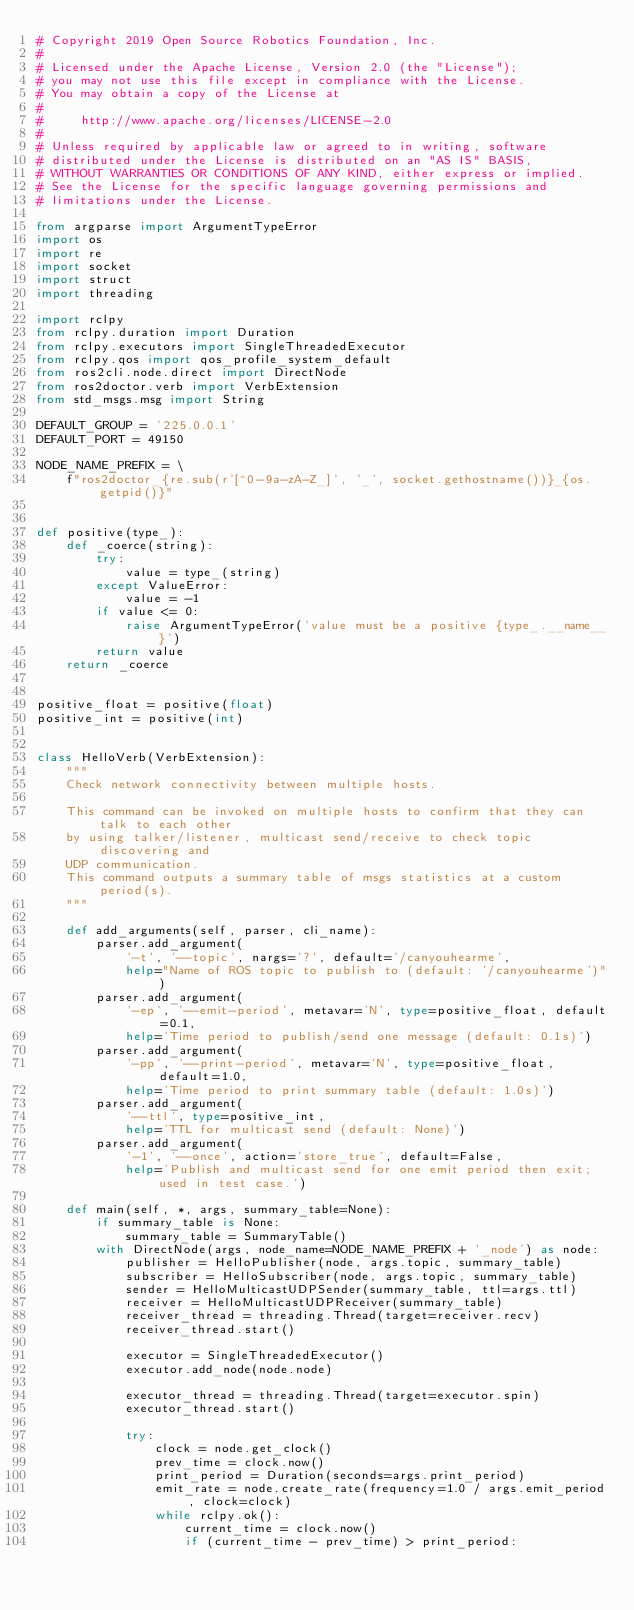<code> <loc_0><loc_0><loc_500><loc_500><_Python_># Copyright 2019 Open Source Robotics Foundation, Inc.
#
# Licensed under the Apache License, Version 2.0 (the "License");
# you may not use this file except in compliance with the License.
# You may obtain a copy of the License at
#
#     http://www.apache.org/licenses/LICENSE-2.0
#
# Unless required by applicable law or agreed to in writing, software
# distributed under the License is distributed on an "AS IS" BASIS,
# WITHOUT WARRANTIES OR CONDITIONS OF ANY KIND, either express or implied.
# See the License for the specific language governing permissions and
# limitations under the License.

from argparse import ArgumentTypeError
import os
import re
import socket
import struct
import threading

import rclpy
from rclpy.duration import Duration
from rclpy.executors import SingleThreadedExecutor
from rclpy.qos import qos_profile_system_default
from ros2cli.node.direct import DirectNode
from ros2doctor.verb import VerbExtension
from std_msgs.msg import String

DEFAULT_GROUP = '225.0.0.1'
DEFAULT_PORT = 49150

NODE_NAME_PREFIX = \
    f"ros2doctor_{re.sub(r'[^0-9a-zA-Z_]', '_', socket.gethostname())}_{os.getpid()}"


def positive(type_):
    def _coerce(string):
        try:
            value = type_(string)
        except ValueError:
            value = -1
        if value <= 0:
            raise ArgumentTypeError('value must be a positive {type_.__name__}')
        return value
    return _coerce


positive_float = positive(float)
positive_int = positive(int)


class HelloVerb(VerbExtension):
    """
    Check network connectivity between multiple hosts.

    This command can be invoked on multiple hosts to confirm that they can talk to each other
    by using talker/listener, multicast send/receive to check topic discovering and
    UDP communication.
    This command outputs a summary table of msgs statistics at a custom period(s).
    """

    def add_arguments(self, parser, cli_name):
        parser.add_argument(
            '-t', '--topic', nargs='?', default='/canyouhearme',
            help="Name of ROS topic to publish to (default: '/canyouhearme')")
        parser.add_argument(
            '-ep', '--emit-period', metavar='N', type=positive_float, default=0.1,
            help='Time period to publish/send one message (default: 0.1s)')
        parser.add_argument(
            '-pp', '--print-period', metavar='N', type=positive_float, default=1.0,
            help='Time period to print summary table (default: 1.0s)')
        parser.add_argument(
            '--ttl', type=positive_int,
            help='TTL for multicast send (default: None)')
        parser.add_argument(
            '-1', '--once', action='store_true', default=False,
            help='Publish and multicast send for one emit period then exit; used in test case.')

    def main(self, *, args, summary_table=None):
        if summary_table is None:
            summary_table = SummaryTable()
        with DirectNode(args, node_name=NODE_NAME_PREFIX + '_node') as node:
            publisher = HelloPublisher(node, args.topic, summary_table)
            subscriber = HelloSubscriber(node, args.topic, summary_table)
            sender = HelloMulticastUDPSender(summary_table, ttl=args.ttl)
            receiver = HelloMulticastUDPReceiver(summary_table)
            receiver_thread = threading.Thread(target=receiver.recv)
            receiver_thread.start()

            executor = SingleThreadedExecutor()
            executor.add_node(node.node)

            executor_thread = threading.Thread(target=executor.spin)
            executor_thread.start()

            try:
                clock = node.get_clock()
                prev_time = clock.now()
                print_period = Duration(seconds=args.print_period)
                emit_rate = node.create_rate(frequency=1.0 / args.emit_period, clock=clock)
                while rclpy.ok():
                    current_time = clock.now()
                    if (current_time - prev_time) > print_period:</code> 